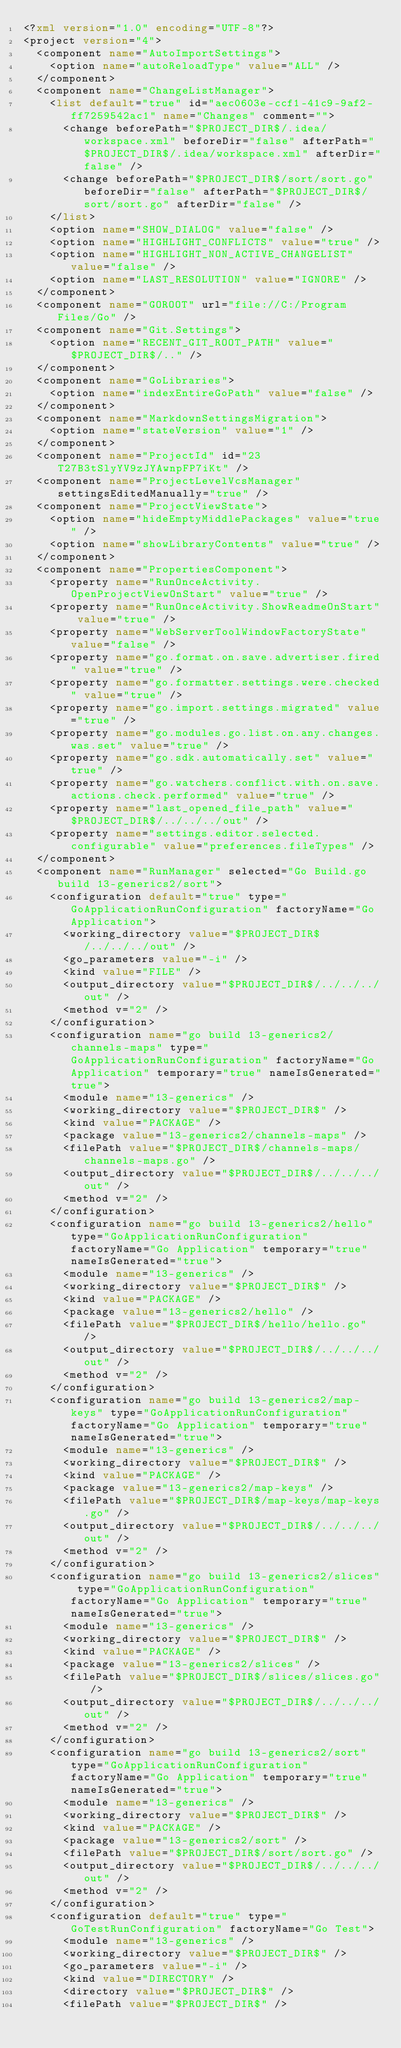<code> <loc_0><loc_0><loc_500><loc_500><_XML_><?xml version="1.0" encoding="UTF-8"?>
<project version="4">
  <component name="AutoImportSettings">
    <option name="autoReloadType" value="ALL" />
  </component>
  <component name="ChangeListManager">
    <list default="true" id="aec0603e-ccf1-41c9-9af2-ff7259542ac1" name="Changes" comment="">
      <change beforePath="$PROJECT_DIR$/.idea/workspace.xml" beforeDir="false" afterPath="$PROJECT_DIR$/.idea/workspace.xml" afterDir="false" />
      <change beforePath="$PROJECT_DIR$/sort/sort.go" beforeDir="false" afterPath="$PROJECT_DIR$/sort/sort.go" afterDir="false" />
    </list>
    <option name="SHOW_DIALOG" value="false" />
    <option name="HIGHLIGHT_CONFLICTS" value="true" />
    <option name="HIGHLIGHT_NON_ACTIVE_CHANGELIST" value="false" />
    <option name="LAST_RESOLUTION" value="IGNORE" />
  </component>
  <component name="GOROOT" url="file://C:/Program Files/Go" />
  <component name="Git.Settings">
    <option name="RECENT_GIT_ROOT_PATH" value="$PROJECT_DIR$/.." />
  </component>
  <component name="GoLibraries">
    <option name="indexEntireGoPath" value="false" />
  </component>
  <component name="MarkdownSettingsMigration">
    <option name="stateVersion" value="1" />
  </component>
  <component name="ProjectId" id="23T27B3tSlyYV9zJYAwnpFP7iKt" />
  <component name="ProjectLevelVcsManager" settingsEditedManually="true" />
  <component name="ProjectViewState">
    <option name="hideEmptyMiddlePackages" value="true" />
    <option name="showLibraryContents" value="true" />
  </component>
  <component name="PropertiesComponent">
    <property name="RunOnceActivity.OpenProjectViewOnStart" value="true" />
    <property name="RunOnceActivity.ShowReadmeOnStart" value="true" />
    <property name="WebServerToolWindowFactoryState" value="false" />
    <property name="go.format.on.save.advertiser.fired" value="true" />
    <property name="go.formatter.settings.were.checked" value="true" />
    <property name="go.import.settings.migrated" value="true" />
    <property name="go.modules.go.list.on.any.changes.was.set" value="true" />
    <property name="go.sdk.automatically.set" value="true" />
    <property name="go.watchers.conflict.with.on.save.actions.check.performed" value="true" />
    <property name="last_opened_file_path" value="$PROJECT_DIR$/../../../out" />
    <property name="settings.editor.selected.configurable" value="preferences.fileTypes" />
  </component>
  <component name="RunManager" selected="Go Build.go build 13-generics2/sort">
    <configuration default="true" type="GoApplicationRunConfiguration" factoryName="Go Application">
      <working_directory value="$PROJECT_DIR$/../../../out" />
      <go_parameters value="-i" />
      <kind value="FILE" />
      <output_directory value="$PROJECT_DIR$/../../../out" />
      <method v="2" />
    </configuration>
    <configuration name="go build 13-generics2/channels-maps" type="GoApplicationRunConfiguration" factoryName="Go Application" temporary="true" nameIsGenerated="true">
      <module name="13-generics" />
      <working_directory value="$PROJECT_DIR$" />
      <kind value="PACKAGE" />
      <package value="13-generics2/channels-maps" />
      <filePath value="$PROJECT_DIR$/channels-maps/channels-maps.go" />
      <output_directory value="$PROJECT_DIR$/../../../out" />
      <method v="2" />
    </configuration>
    <configuration name="go build 13-generics2/hello" type="GoApplicationRunConfiguration" factoryName="Go Application" temporary="true" nameIsGenerated="true">
      <module name="13-generics" />
      <working_directory value="$PROJECT_DIR$" />
      <kind value="PACKAGE" />
      <package value="13-generics2/hello" />
      <filePath value="$PROJECT_DIR$/hello/hello.go" />
      <output_directory value="$PROJECT_DIR$/../../../out" />
      <method v="2" />
    </configuration>
    <configuration name="go build 13-generics2/map-keys" type="GoApplicationRunConfiguration" factoryName="Go Application" temporary="true" nameIsGenerated="true">
      <module name="13-generics" />
      <working_directory value="$PROJECT_DIR$" />
      <kind value="PACKAGE" />
      <package value="13-generics2/map-keys" />
      <filePath value="$PROJECT_DIR$/map-keys/map-keys.go" />
      <output_directory value="$PROJECT_DIR$/../../../out" />
      <method v="2" />
    </configuration>
    <configuration name="go build 13-generics2/slices" type="GoApplicationRunConfiguration" factoryName="Go Application" temporary="true" nameIsGenerated="true">
      <module name="13-generics" />
      <working_directory value="$PROJECT_DIR$" />
      <kind value="PACKAGE" />
      <package value="13-generics2/slices" />
      <filePath value="$PROJECT_DIR$/slices/slices.go" />
      <output_directory value="$PROJECT_DIR$/../../../out" />
      <method v="2" />
    </configuration>
    <configuration name="go build 13-generics2/sort" type="GoApplicationRunConfiguration" factoryName="Go Application" temporary="true" nameIsGenerated="true">
      <module name="13-generics" />
      <working_directory value="$PROJECT_DIR$" />
      <kind value="PACKAGE" />
      <package value="13-generics2/sort" />
      <filePath value="$PROJECT_DIR$/sort/sort.go" />
      <output_directory value="$PROJECT_DIR$/../../../out" />
      <method v="2" />
    </configuration>
    <configuration default="true" type="GoTestRunConfiguration" factoryName="Go Test">
      <module name="13-generics" />
      <working_directory value="$PROJECT_DIR$" />
      <go_parameters value="-i" />
      <kind value="DIRECTORY" />
      <directory value="$PROJECT_DIR$" />
      <filePath value="$PROJECT_DIR$" /></code> 